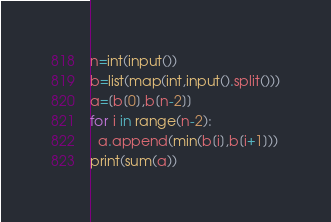<code> <loc_0><loc_0><loc_500><loc_500><_Python_>n=int(input())
b=list(map(int,input().split()))
a=[b[0],b[n-2]]
for i in range(n-2):
  a.append(min(b[i],b[i+1]))
print(sum(a))</code> 